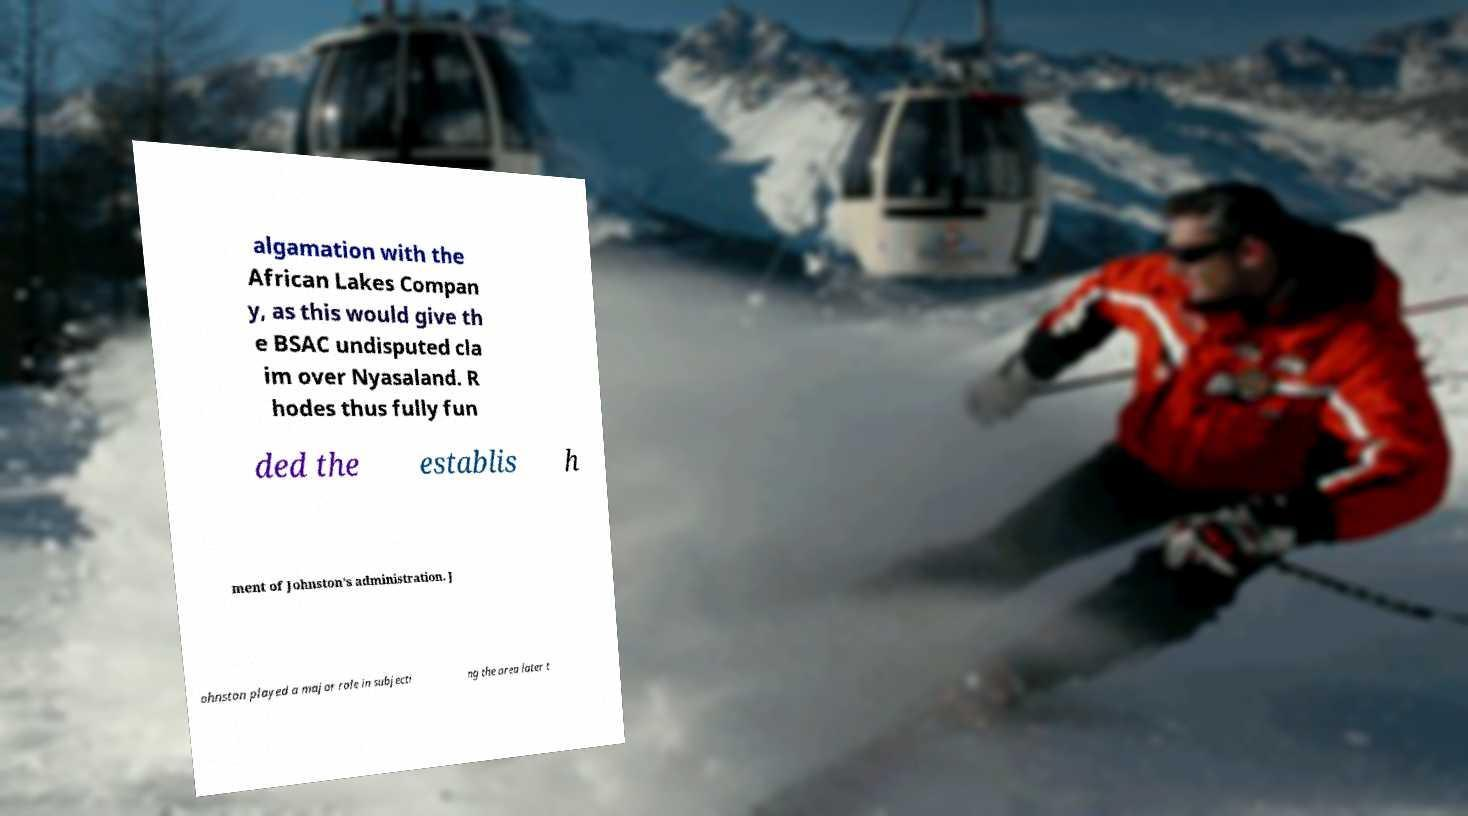Could you assist in decoding the text presented in this image and type it out clearly? algamation with the African Lakes Compan y, as this would give th e BSAC undisputed cla im over Nyasaland. R hodes thus fully fun ded the establis h ment of Johnston’s administration. J ohnston played a major role in subjecti ng the area later t 